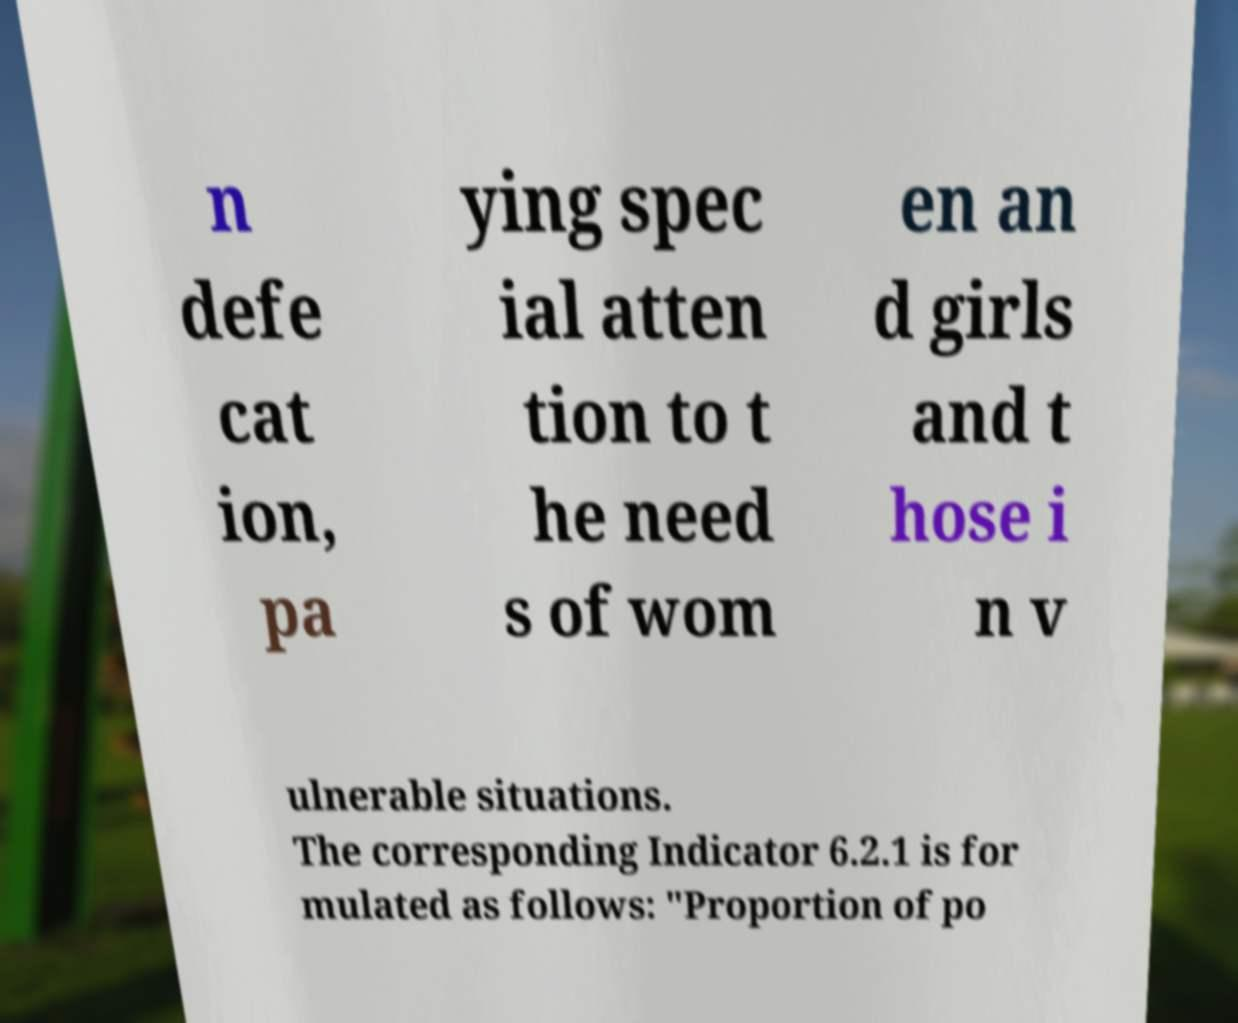Please read and relay the text visible in this image. What does it say? n defe cat ion, pa ying spec ial atten tion to t he need s of wom en an d girls and t hose i n v ulnerable situations. The corresponding Indicator 6.2.1 is for mulated as follows: "Proportion of po 